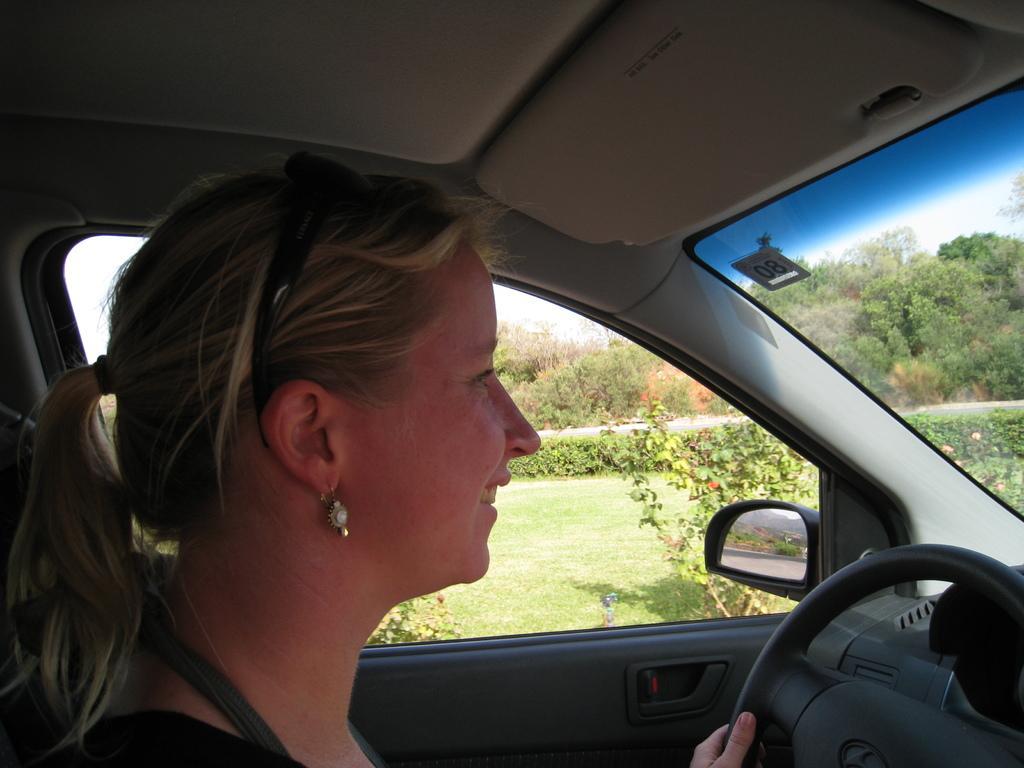Can you describe this image briefly? In this image I see a woman who is smiling and sitting inside the car and she is holding the steering. I can also see planets and the trees through the window and the glass. 